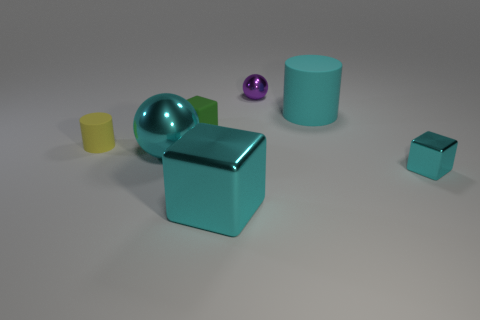The yellow thing that is the same size as the green object is what shape?
Your answer should be compact. Cylinder. Do the shiny sphere behind the big cyan matte cylinder and the matte cylinder that is left of the large cyan metal sphere have the same size?
Provide a short and direct response. Yes. How many large cyan shiny blocks are there?
Give a very brief answer. 1. There is a sphere that is to the right of the cyan metal thing in front of the metallic cube that is right of the tiny purple metal sphere; what is its size?
Provide a succinct answer. Small. Is the large rubber thing the same color as the large block?
Your answer should be very brief. Yes. What number of large cyan things are to the right of the big rubber object?
Provide a succinct answer. 0. Are there an equal number of cubes that are behind the cyan rubber object and large shiny things?
Offer a very short reply. No. What number of things are tiny purple things or big cyan cubes?
Provide a short and direct response. 2. There is a tiny rubber thing behind the tiny yellow matte cylinder that is on the left side of the rubber cube; what shape is it?
Your answer should be very brief. Cube. There is a large object that is the same material as the big ball; what shape is it?
Provide a succinct answer. Cube. 